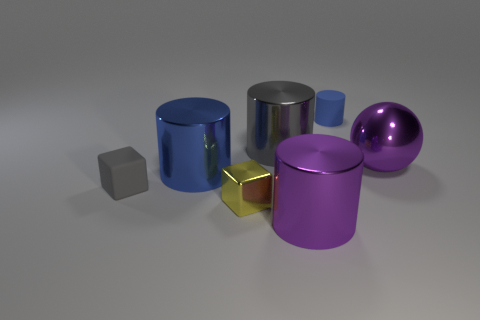Subtract all yellow cubes. How many blue cylinders are left? 2 Subtract all gray cylinders. How many cylinders are left? 3 Subtract all metallic cylinders. How many cylinders are left? 1 Add 2 gray cylinders. How many objects exist? 9 Subtract all yellow cylinders. Subtract all cyan balls. How many cylinders are left? 4 Subtract all cylinders. How many objects are left? 3 Subtract all big brown metallic balls. Subtract all big metal things. How many objects are left? 3 Add 5 large purple spheres. How many large purple spheres are left? 6 Add 3 tiny cylinders. How many tiny cylinders exist? 4 Subtract 0 brown cylinders. How many objects are left? 7 